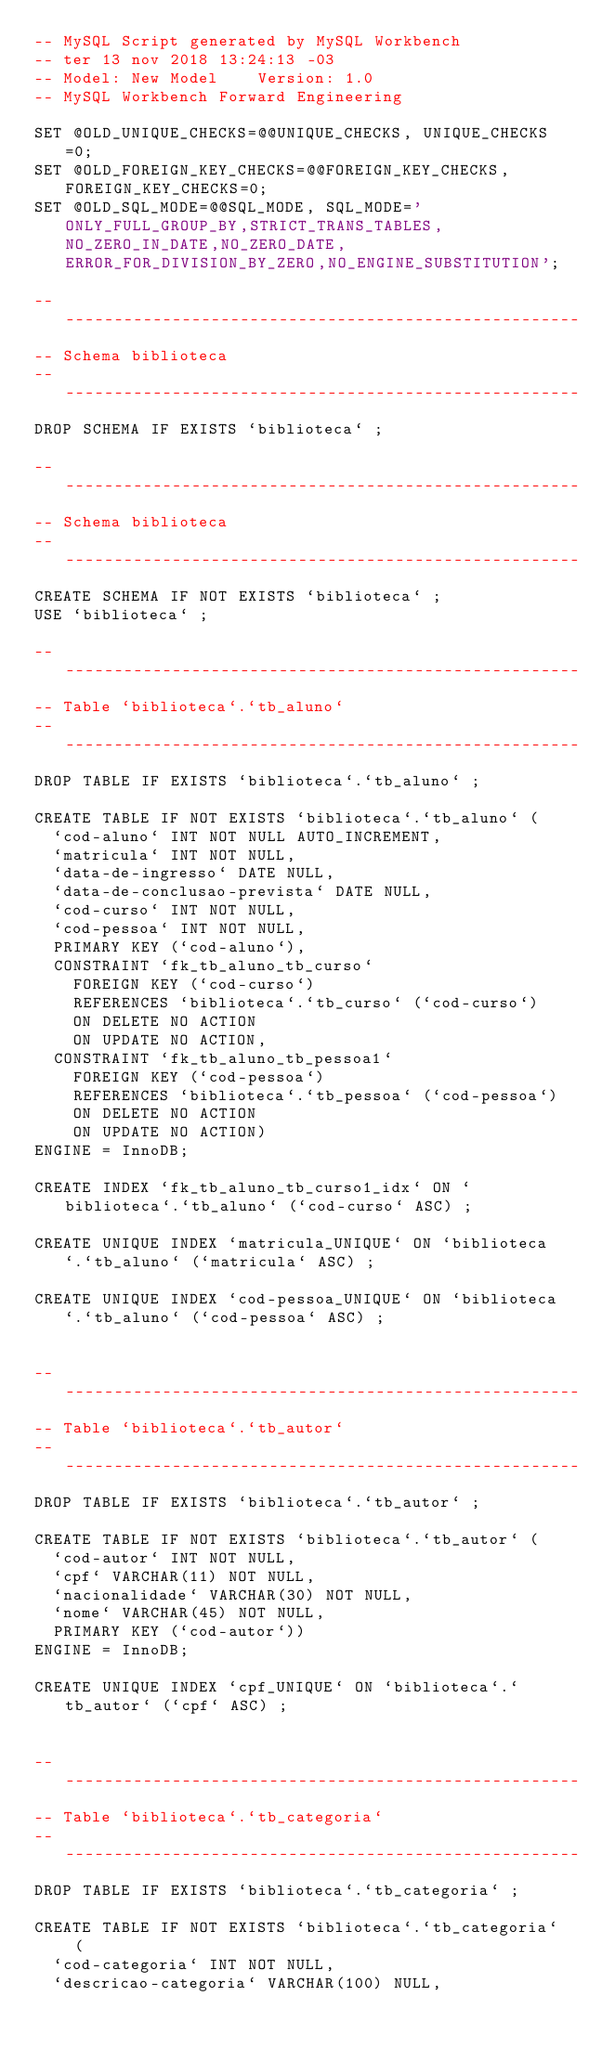<code> <loc_0><loc_0><loc_500><loc_500><_SQL_>-- MySQL Script generated by MySQL Workbench
-- ter 13 nov 2018 13:24:13 -03
-- Model: New Model    Version: 1.0
-- MySQL Workbench Forward Engineering

SET @OLD_UNIQUE_CHECKS=@@UNIQUE_CHECKS, UNIQUE_CHECKS=0;
SET @OLD_FOREIGN_KEY_CHECKS=@@FOREIGN_KEY_CHECKS, FOREIGN_KEY_CHECKS=0;
SET @OLD_SQL_MODE=@@SQL_MODE, SQL_MODE='ONLY_FULL_GROUP_BY,STRICT_TRANS_TABLES,NO_ZERO_IN_DATE,NO_ZERO_DATE,ERROR_FOR_DIVISION_BY_ZERO,NO_ENGINE_SUBSTITUTION';

-- -----------------------------------------------------
-- Schema biblioteca
-- -----------------------------------------------------
DROP SCHEMA IF EXISTS `biblioteca` ;

-- -----------------------------------------------------
-- Schema biblioteca
-- -----------------------------------------------------
CREATE SCHEMA IF NOT EXISTS `biblioteca` ;
USE `biblioteca` ;

-- -----------------------------------------------------
-- Table `biblioteca`.`tb_aluno`
-- -----------------------------------------------------
DROP TABLE IF EXISTS `biblioteca`.`tb_aluno` ;

CREATE TABLE IF NOT EXISTS `biblioteca`.`tb_aluno` (
  `cod-aluno` INT NOT NULL AUTO_INCREMENT,
  `matricula` INT NOT NULL,
  `data-de-ingresso` DATE NULL,
  `data-de-conclusao-prevista` DATE NULL,
  `cod-curso` INT NOT NULL,
  `cod-pessoa` INT NOT NULL,
  PRIMARY KEY (`cod-aluno`),
  CONSTRAINT `fk_tb_aluno_tb_curso`
    FOREIGN KEY (`cod-curso`)
    REFERENCES `biblioteca`.`tb_curso` (`cod-curso`)
    ON DELETE NO ACTION
    ON UPDATE NO ACTION,
  CONSTRAINT `fk_tb_aluno_tb_pessoa1`
    FOREIGN KEY (`cod-pessoa`)
    REFERENCES `biblioteca`.`tb_pessoa` (`cod-pessoa`)
    ON DELETE NO ACTION
    ON UPDATE NO ACTION)
ENGINE = InnoDB;

CREATE INDEX `fk_tb_aluno_tb_curso1_idx` ON `biblioteca`.`tb_aluno` (`cod-curso` ASC) ;

CREATE UNIQUE INDEX `matricula_UNIQUE` ON `biblioteca`.`tb_aluno` (`matricula` ASC) ;

CREATE UNIQUE INDEX `cod-pessoa_UNIQUE` ON `biblioteca`.`tb_aluno` (`cod-pessoa` ASC) ;


-- -----------------------------------------------------
-- Table `biblioteca`.`tb_autor`
-- -----------------------------------------------------
DROP TABLE IF EXISTS `biblioteca`.`tb_autor` ;

CREATE TABLE IF NOT EXISTS `biblioteca`.`tb_autor` (
  `cod-autor` INT NOT NULL,
  `cpf` VARCHAR(11) NOT NULL,
  `nacionalidade` VARCHAR(30) NOT NULL,
  `nome` VARCHAR(45) NOT NULL,
  PRIMARY KEY (`cod-autor`))
ENGINE = InnoDB;

CREATE UNIQUE INDEX `cpf_UNIQUE` ON `biblioteca`.`tb_autor` (`cpf` ASC) ;


-- -----------------------------------------------------
-- Table `biblioteca`.`tb_categoria`
-- -----------------------------------------------------
DROP TABLE IF EXISTS `biblioteca`.`tb_categoria` ;

CREATE TABLE IF NOT EXISTS `biblioteca`.`tb_categoria` (
  `cod-categoria` INT NOT NULL,
  `descricao-categoria` VARCHAR(100) NULL,</code> 